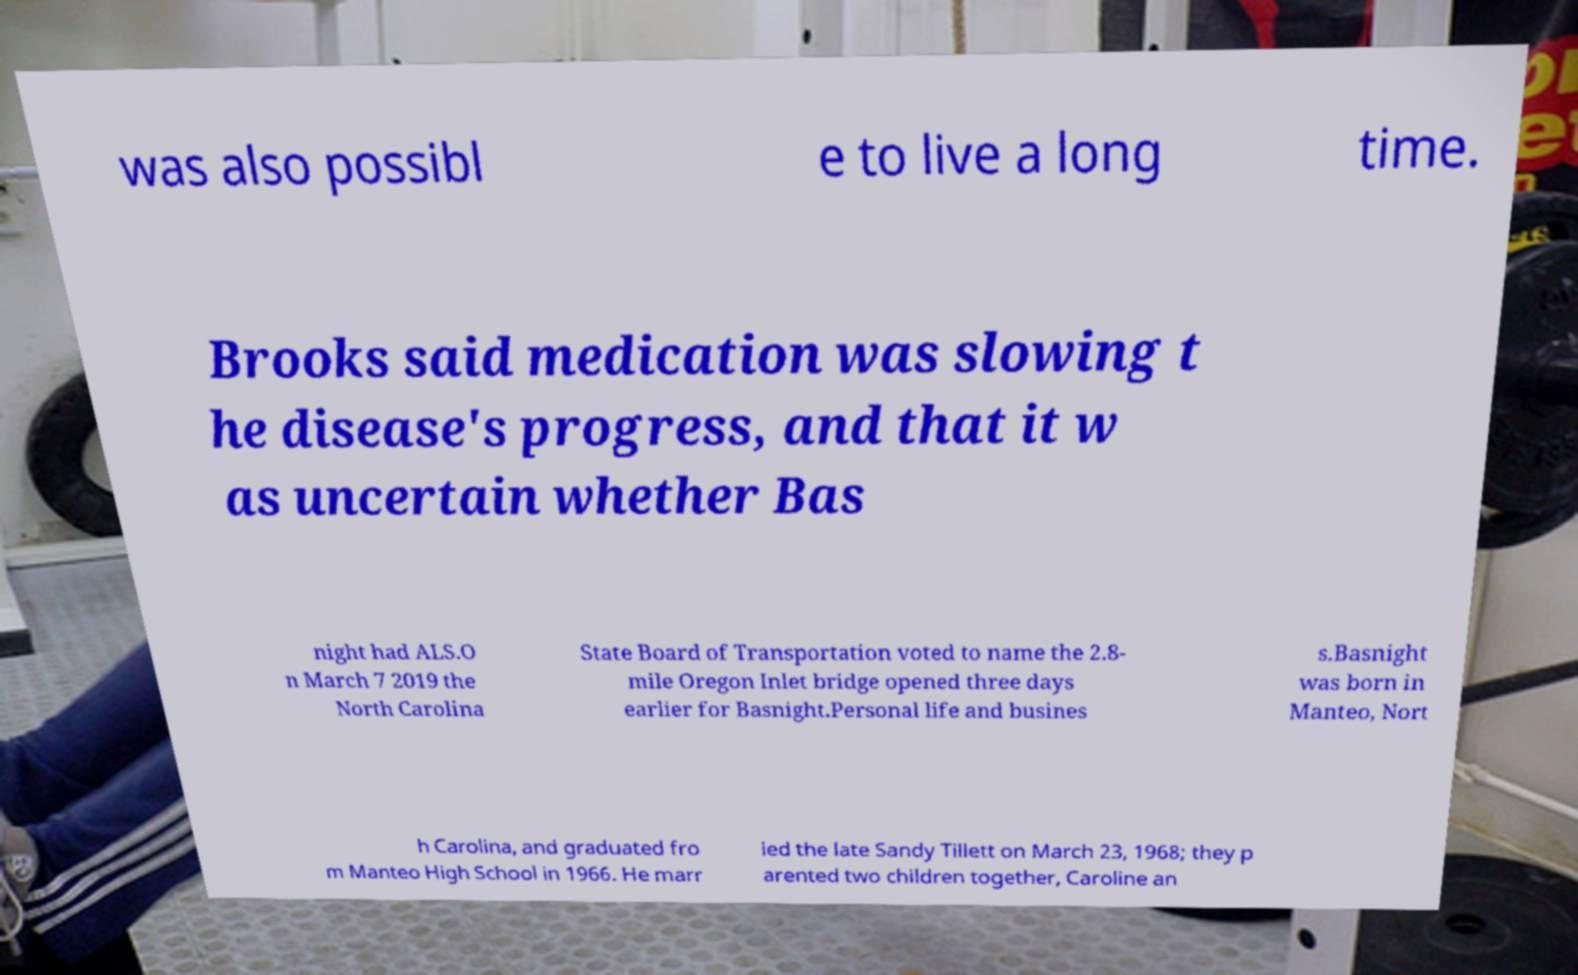There's text embedded in this image that I need extracted. Can you transcribe it verbatim? was also possibl e to live a long time. Brooks said medication was slowing t he disease's progress, and that it w as uncertain whether Bas night had ALS.O n March 7 2019 the North Carolina State Board of Transportation voted to name the 2.8- mile Oregon Inlet bridge opened three days earlier for Basnight.Personal life and busines s.Basnight was born in Manteo, Nort h Carolina, and graduated fro m Manteo High School in 1966. He marr ied the late Sandy Tillett on March 23, 1968; they p arented two children together, Caroline an 